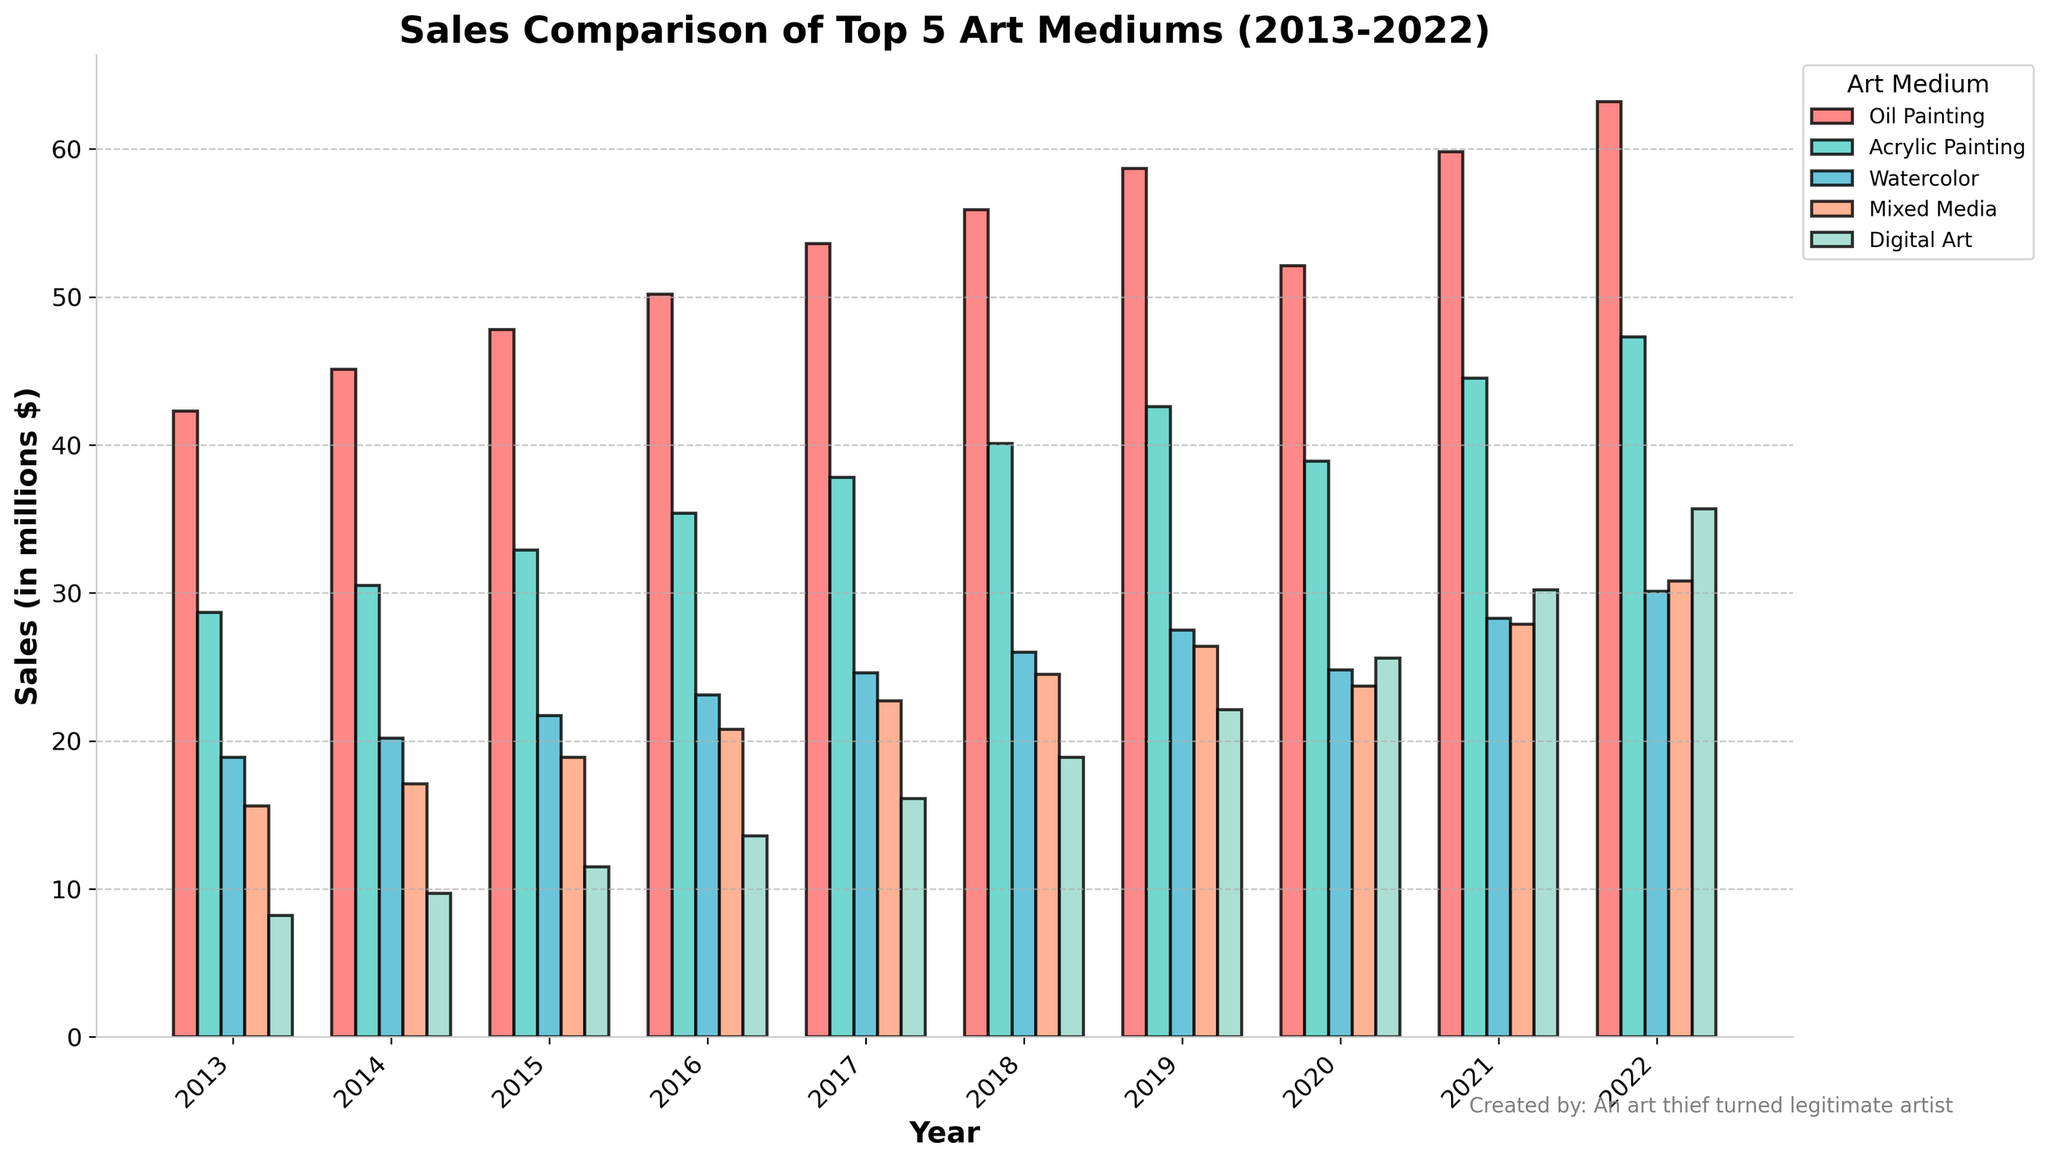Which medium had the highest sales in 2022? Look at the height of the bars for the year 2022. The highest bar represents Oil Painting.
Answer: Oil Painting Which year saw the highest sales for Digital Art? Compare the heights of the bars for Digital Art across all years on the x-axis. The highest bar is for 2022.
Answer: 2022 Which medium experienced a decline in sales from 2019 to 2020? Check the bars for each medium between 2019 and 2020. The sales for Oil Painting declined.
Answer: Oil Painting How much did the sales of Mixed Media increase from 2013 to 2022? Subtract the 2013 value of Mixed Media sales from the 2022 value (30.8 - 15.6).
Answer: 15.2 Which medium had the most significant growth in sales from 2013 to 2022? Calculate the difference between 2022 and 2013 values for each medium. Digital Art grew from 8.2 to 35.7, which is the largest increase among all.
Answer: Digital Art How many mediums had sales greater than 40 million dollars in 2022? Count the number of bars exceeding 40 million dollars for the year 2022. Four mediums had sales greater than 40 million dollars: Oil Painting, Acrylic Painting, Watercolor, and Mixed Media.
Answer: 4 In which year did Acrylic Painting sales first surpass 40 million dollars? Examine the heights of the bars for Acrylic Painting and find the first year where it crosses 40 million dollars, which is 2018.
Answer: 2018 What was the combined sales of Watercolor and Mixed Media in 2017? Sum the values of Watercolor and Mixed Media for the year 2017 (24.6 + 22.7).
Answer: 47.3 Which medium consistently showed an upward trend in sales every year from 2013 to 2022? Find a medium whose bar heights increase every year without any decline. Digital Art shows a consistent upward trend.
Answer: Digital Art What is the difference in sales between Oil Painting and Acrylic Painting in 2021? Subtract the 2021 value of Acrylic Painting from Oil Painting (59.8 - 44.5).
Answer: 15.3 